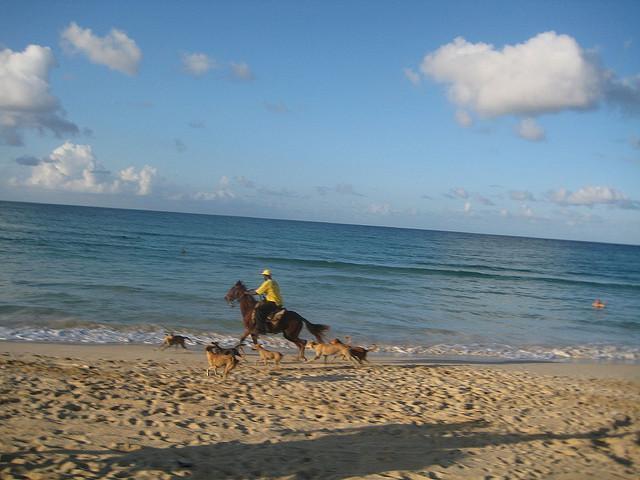How many chairs are behind the pole?
Give a very brief answer. 0. 